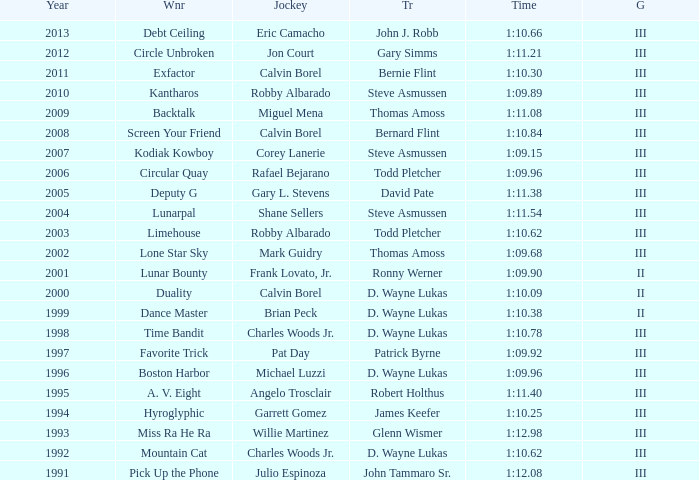What was the time for Screen Your Friend? 1:10.84. 